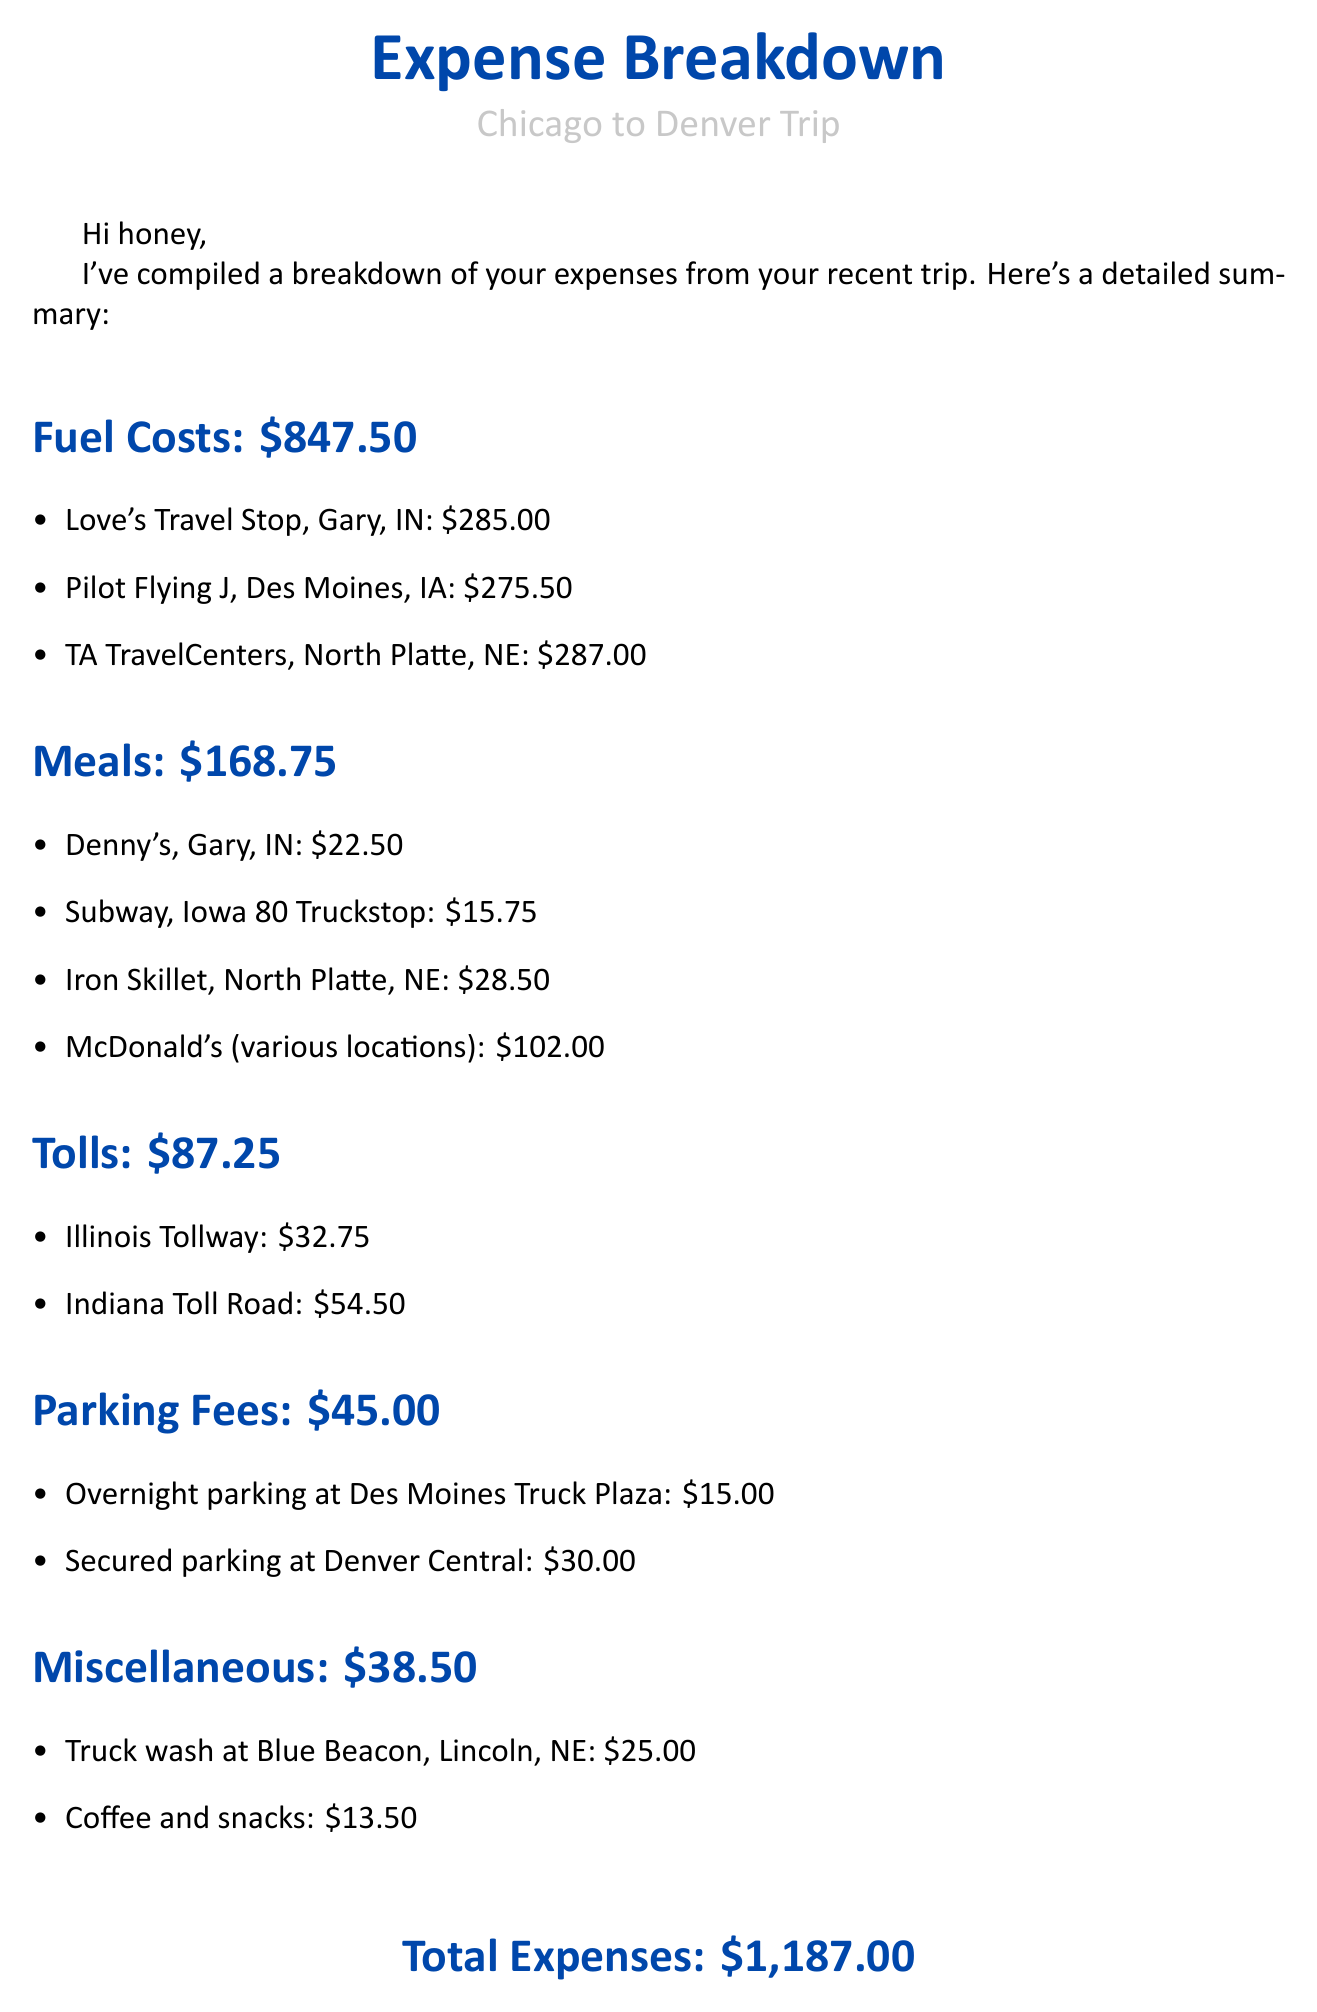What is the total fuel cost? The total fuel cost is the sum of the individual fuel charges listed in the document, which is $285.00 + $275.50 + $287.00.
Answer: $847.50 How much did he spend on meals? The total amount spent on meals is specified directly in the document.
Answer: $168.75 What was the total amount spent on tolls? The total amount spent on tolls is presented clearly in the document.
Answer: $87.25 How much did he pay for parking fees? The total paid for parking is shown as a sum of parking charges in the document.
Answer: $45.00 What was the charge for truck wash? The specific cost for the truck wash service is mentioned in the miscellaneous section.
Answer: $25.00 How much did he spend at McDonald's? The spending at McDonald's is specified as part of the meal breakdown.
Answer: $102.00 What is the total expense for this trip? The total expenses is presented as the final sum of all categories in the document.
Answer: $1,187.00 What type of document is this? This document is an email summarizing expenses from a trip.
Answer: Email Which locations did he visit during the trip? The document lists the cities relevant to the trip in the expense breakdown.
Answer: Chicago to Denver 